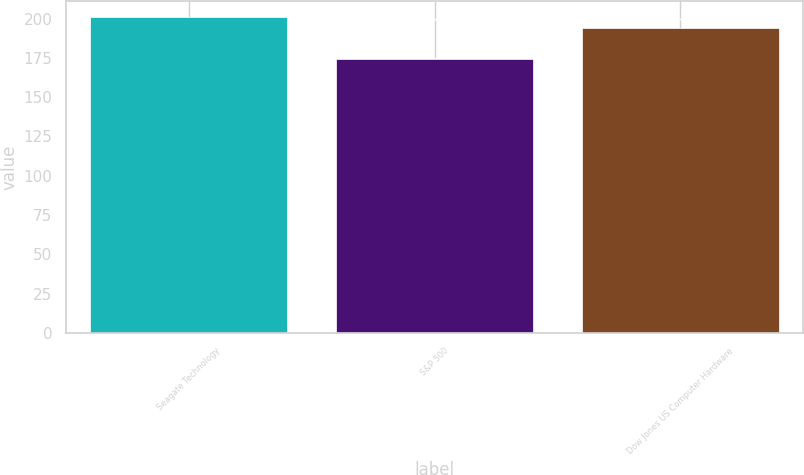Convert chart to OTSL. <chart><loc_0><loc_0><loc_500><loc_500><bar_chart><fcel>Seagate Technology<fcel>S&P 500<fcel>Dow Jones US Computer Hardware<nl><fcel>200.86<fcel>174.51<fcel>193.8<nl></chart> 